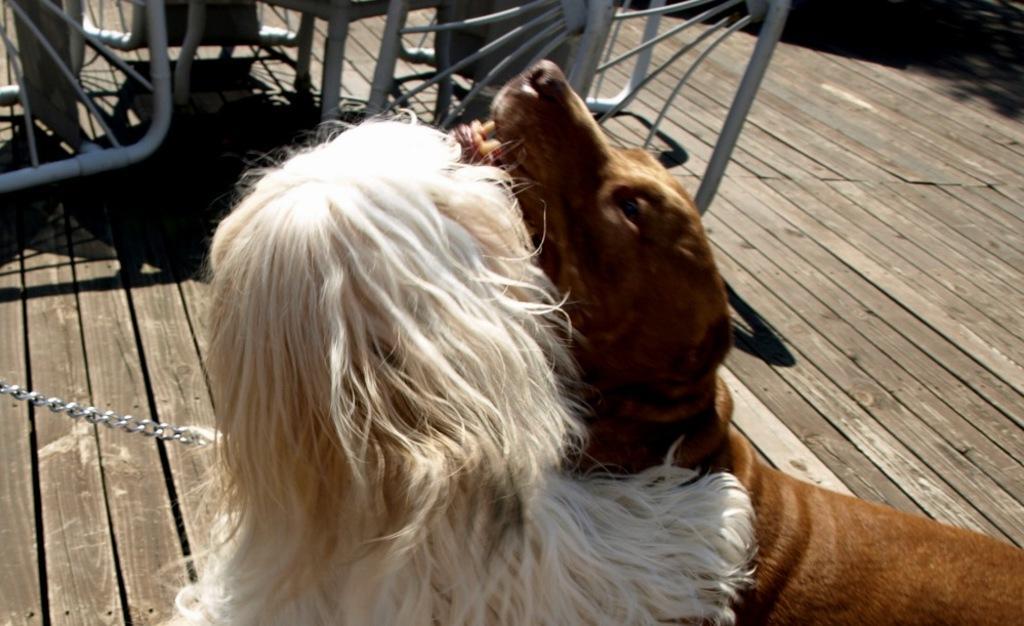Describe this image in one or two sentences. In the foreground of the picture there are two dogs on a wooden floor. At the top there are some iron objects looking like benches. On the left there is an iron chain. 